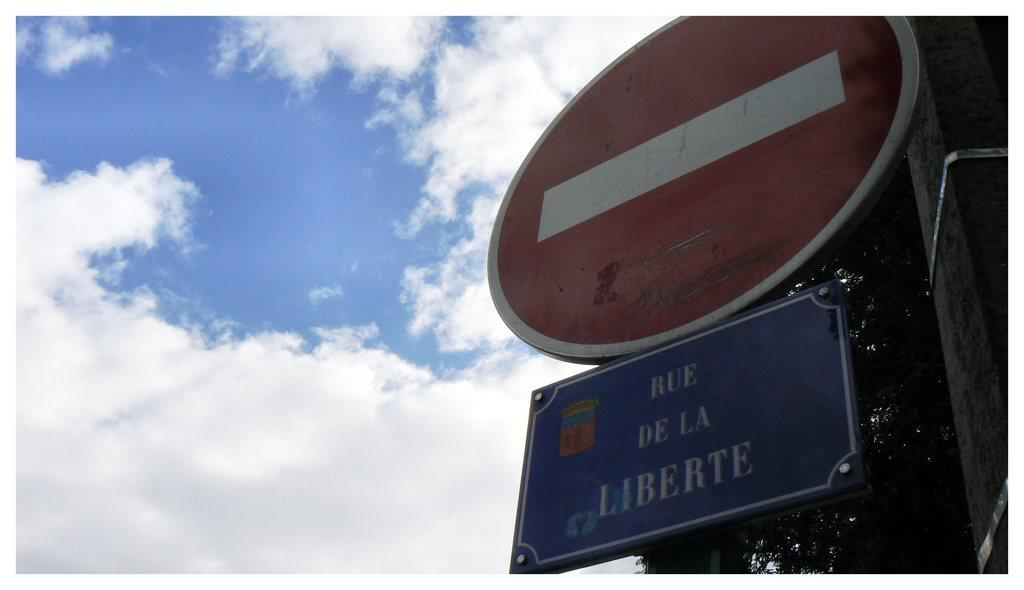<image>
Describe the image concisely. A do not enter sign on top of a blue sign that says Rue De La Liberte. 